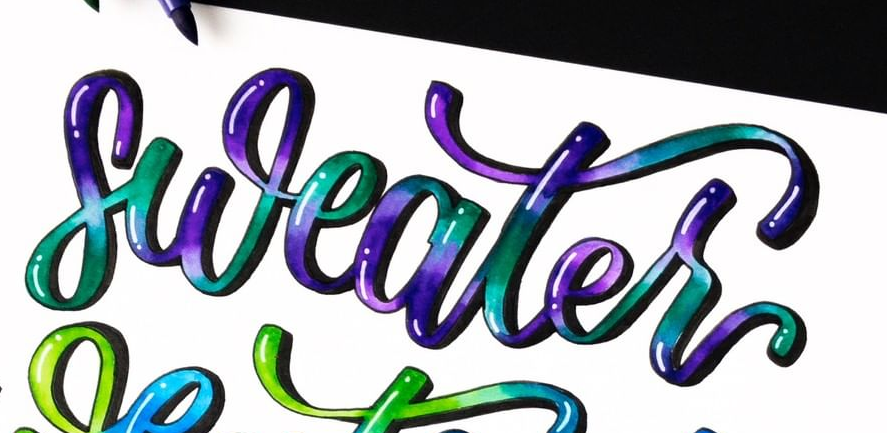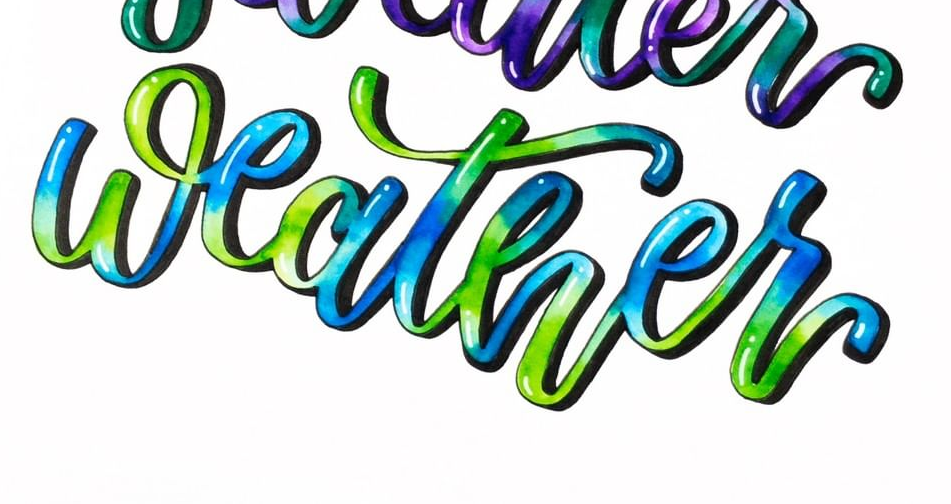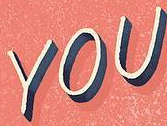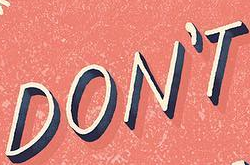Identify the words shown in these images in order, separated by a semicolon. sweater; weather; YOU; DON'T 